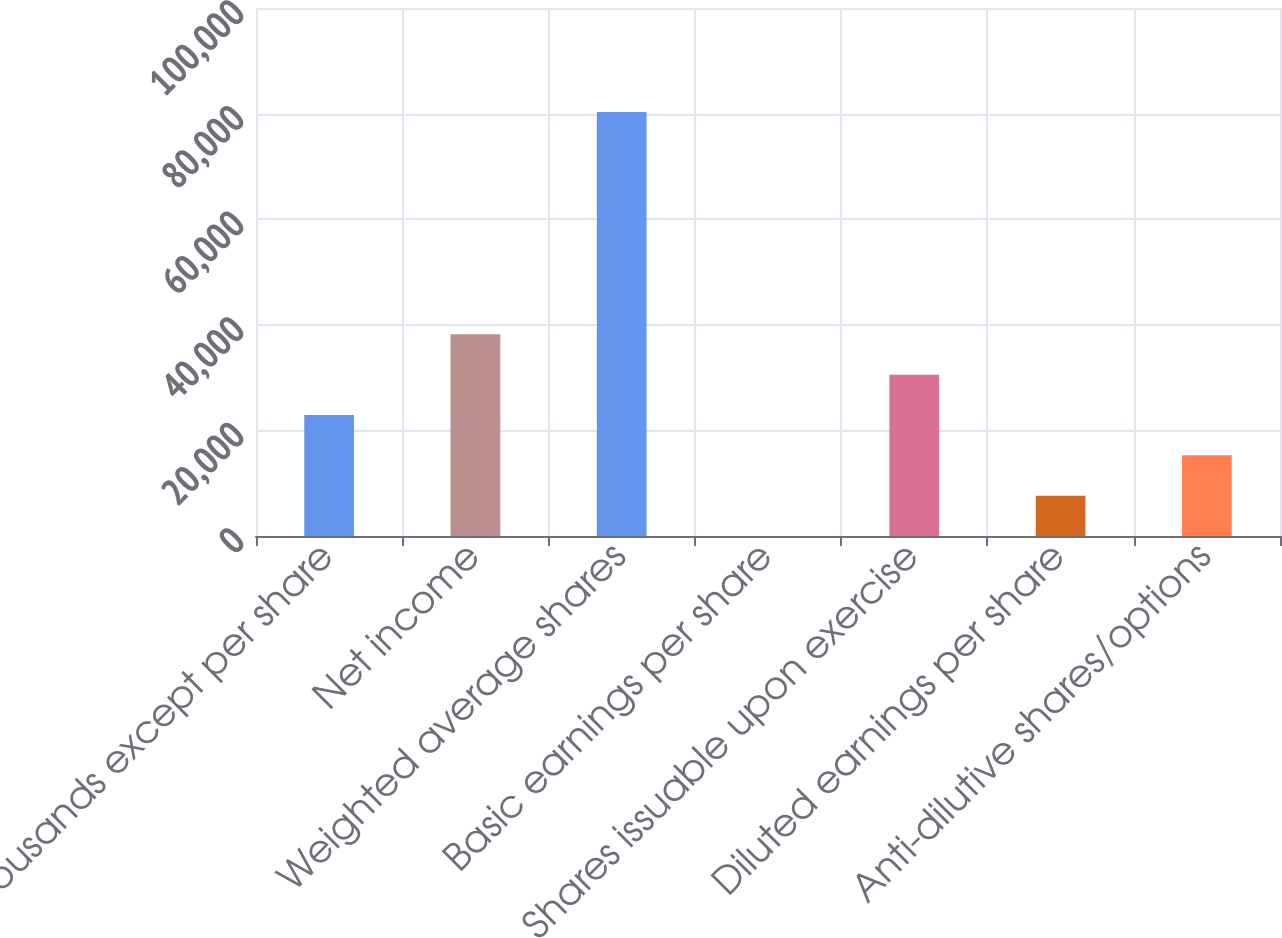<chart> <loc_0><loc_0><loc_500><loc_500><bar_chart><fcel>(in thousands except per share<fcel>Net income<fcel>Weighted average shares<fcel>Basic earnings per share<fcel>Shares issuable upon exercise<fcel>Diluted earnings per share<fcel>Anti-dilutive shares/options<nl><fcel>22919.5<fcel>38199.1<fcel>80325.8<fcel>0.19<fcel>30559.3<fcel>7639.97<fcel>15279.8<nl></chart> 